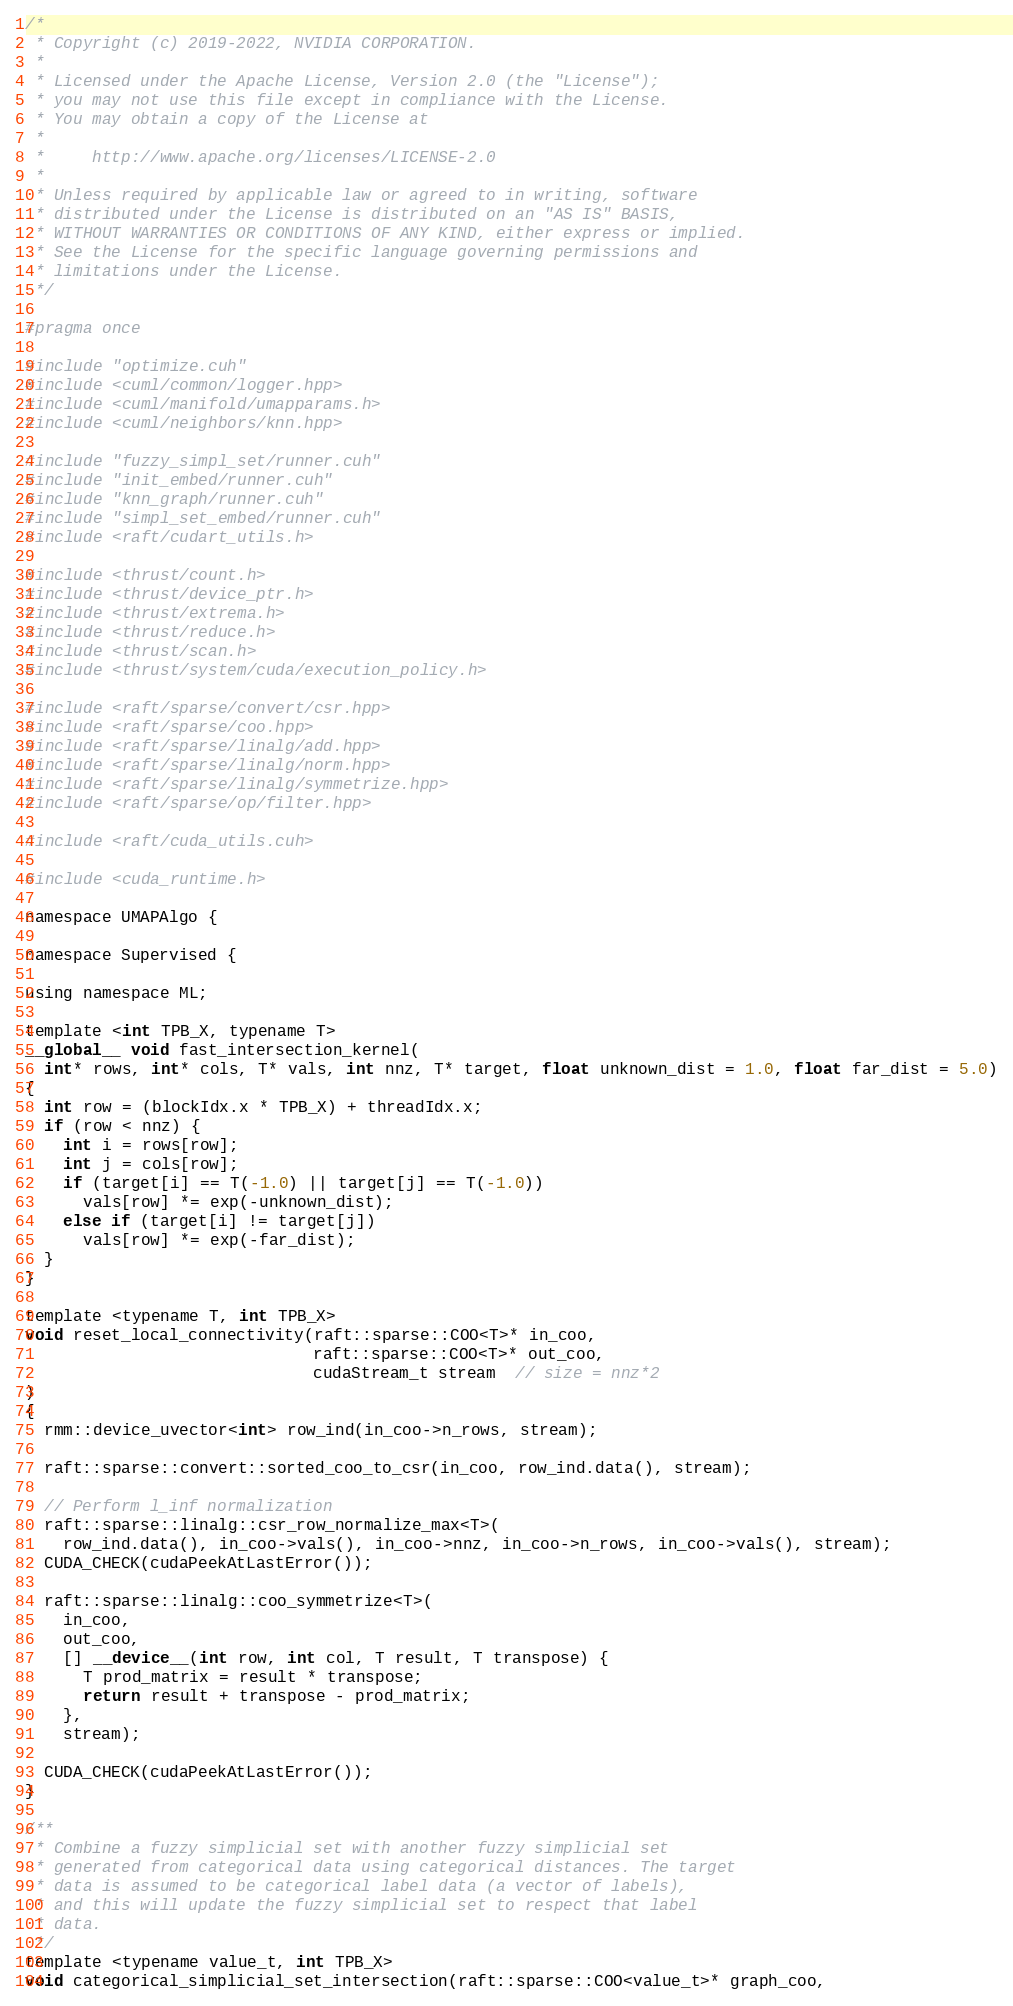Convert code to text. <code><loc_0><loc_0><loc_500><loc_500><_Cuda_>/*
 * Copyright (c) 2019-2022, NVIDIA CORPORATION.
 *
 * Licensed under the Apache License, Version 2.0 (the "License");
 * you may not use this file except in compliance with the License.
 * You may obtain a copy of the License at
 *
 *     http://www.apache.org/licenses/LICENSE-2.0
 *
 * Unless required by applicable law or agreed to in writing, software
 * distributed under the License is distributed on an "AS IS" BASIS,
 * WITHOUT WARRANTIES OR CONDITIONS OF ANY KIND, either express or implied.
 * See the License for the specific language governing permissions and
 * limitations under the License.
 */

#pragma once

#include "optimize.cuh"
#include <cuml/common/logger.hpp>
#include <cuml/manifold/umapparams.h>
#include <cuml/neighbors/knn.hpp>

#include "fuzzy_simpl_set/runner.cuh"
#include "init_embed/runner.cuh"
#include "knn_graph/runner.cuh"
#include "simpl_set_embed/runner.cuh"
#include <raft/cudart_utils.h>

#include <thrust/count.h>
#include <thrust/device_ptr.h>
#include <thrust/extrema.h>
#include <thrust/reduce.h>
#include <thrust/scan.h>
#include <thrust/system/cuda/execution_policy.h>

#include <raft/sparse/convert/csr.hpp>
#include <raft/sparse/coo.hpp>
#include <raft/sparse/linalg/add.hpp>
#include <raft/sparse/linalg/norm.hpp>
#include <raft/sparse/linalg/symmetrize.hpp>
#include <raft/sparse/op/filter.hpp>

#include <raft/cuda_utils.cuh>

#include <cuda_runtime.h>

namespace UMAPAlgo {

namespace Supervised {

using namespace ML;

template <int TPB_X, typename T>
__global__ void fast_intersection_kernel(
  int* rows, int* cols, T* vals, int nnz, T* target, float unknown_dist = 1.0, float far_dist = 5.0)
{
  int row = (blockIdx.x * TPB_X) + threadIdx.x;
  if (row < nnz) {
    int i = rows[row];
    int j = cols[row];
    if (target[i] == T(-1.0) || target[j] == T(-1.0))
      vals[row] *= exp(-unknown_dist);
    else if (target[i] != target[j])
      vals[row] *= exp(-far_dist);
  }
}

template <typename T, int TPB_X>
void reset_local_connectivity(raft::sparse::COO<T>* in_coo,
                              raft::sparse::COO<T>* out_coo,
                              cudaStream_t stream  // size = nnz*2
)
{
  rmm::device_uvector<int> row_ind(in_coo->n_rows, stream);

  raft::sparse::convert::sorted_coo_to_csr(in_coo, row_ind.data(), stream);

  // Perform l_inf normalization
  raft::sparse::linalg::csr_row_normalize_max<T>(
    row_ind.data(), in_coo->vals(), in_coo->nnz, in_coo->n_rows, in_coo->vals(), stream);
  CUDA_CHECK(cudaPeekAtLastError());

  raft::sparse::linalg::coo_symmetrize<T>(
    in_coo,
    out_coo,
    [] __device__(int row, int col, T result, T transpose) {
      T prod_matrix = result * transpose;
      return result + transpose - prod_matrix;
    },
    stream);

  CUDA_CHECK(cudaPeekAtLastError());
}

/**
 * Combine a fuzzy simplicial set with another fuzzy simplicial set
 * generated from categorical data using categorical distances. The target
 * data is assumed to be categorical label data (a vector of labels),
 * and this will update the fuzzy simplicial set to respect that label
 * data.
 */
template <typename value_t, int TPB_X>
void categorical_simplicial_set_intersection(raft::sparse::COO<value_t>* graph_coo,</code> 